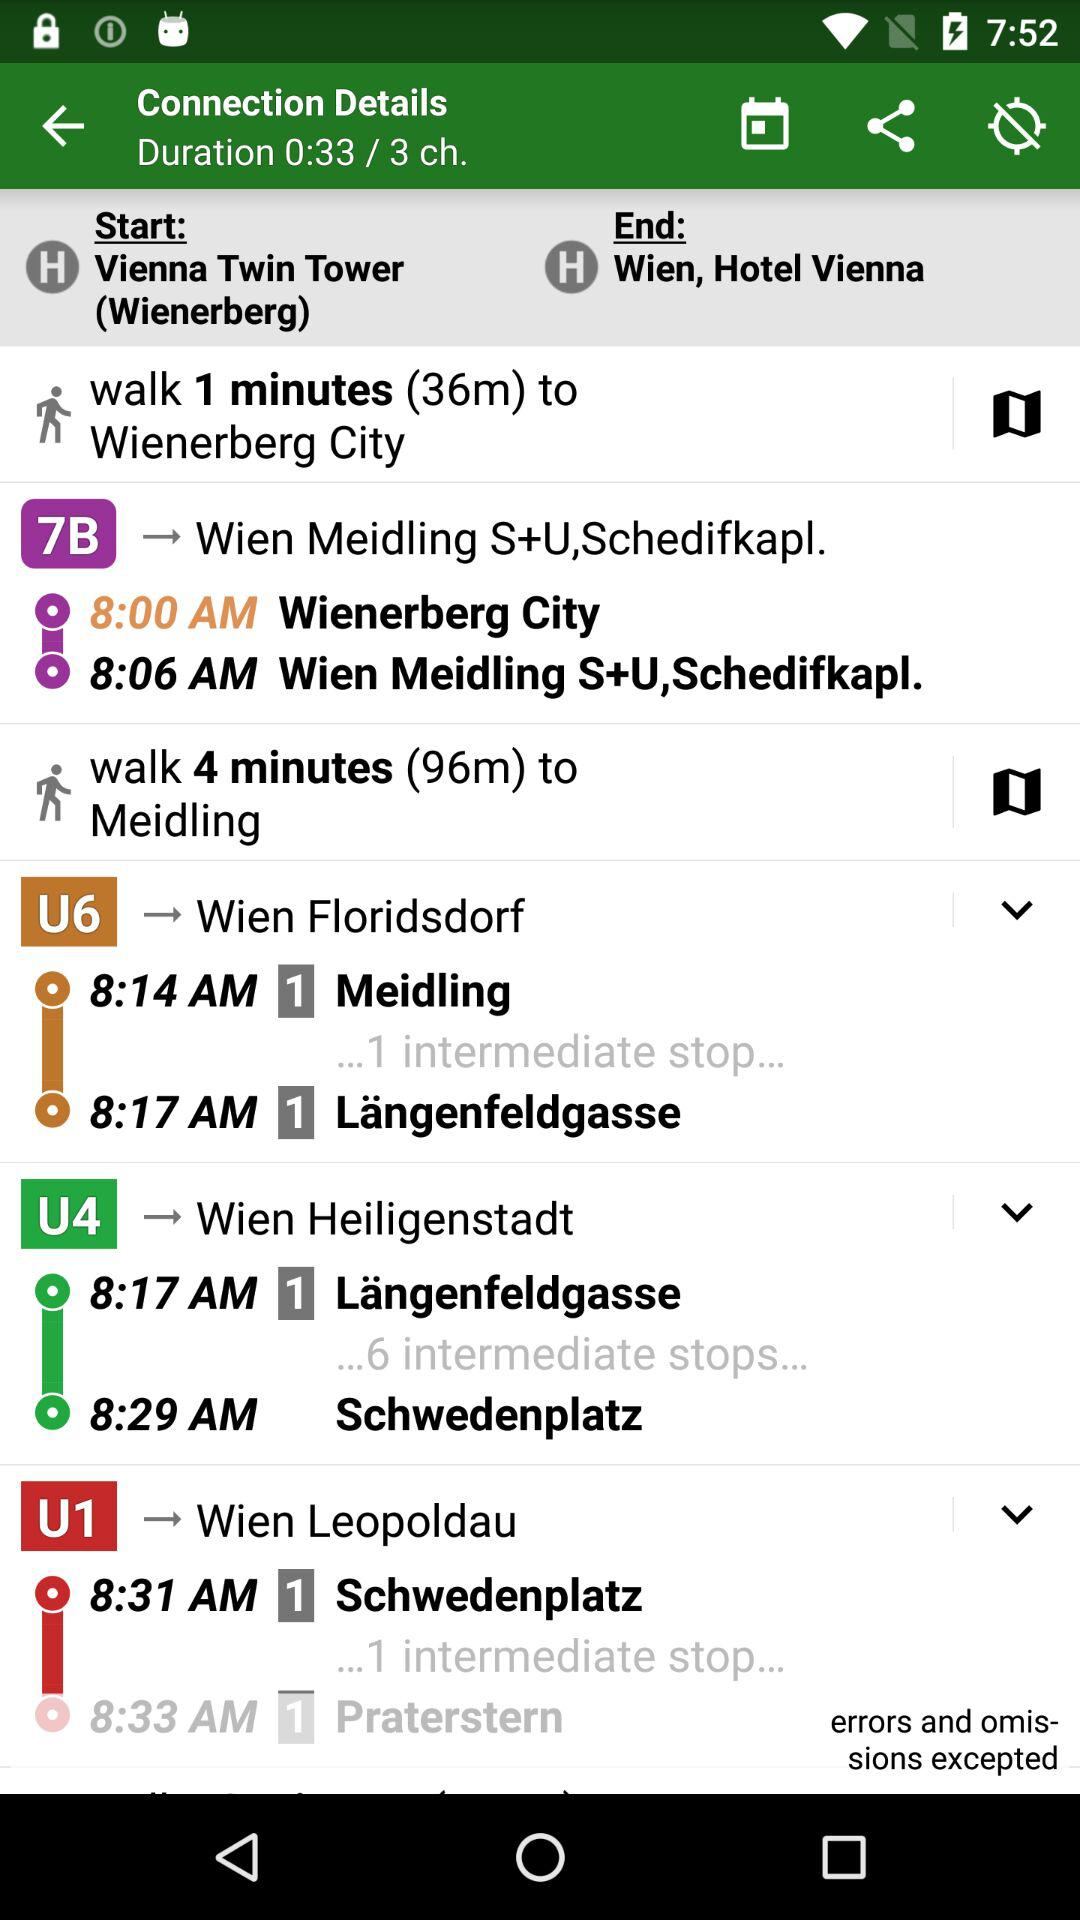How many minutes of walking to reach the Meidling? There are 4 minutes of walking to reach the Meidling. 